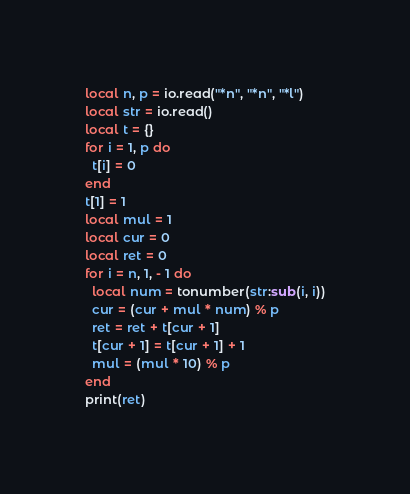<code> <loc_0><loc_0><loc_500><loc_500><_Lua_>local n, p = io.read("*n", "*n", "*l")
local str = io.read()
local t = {}
for i = 1, p do
  t[i] = 0
end
t[1] = 1
local mul = 1
local cur = 0
local ret = 0
for i = n, 1, - 1 do
  local num = tonumber(str:sub(i, i))
  cur = (cur + mul * num) % p
  ret = ret + t[cur + 1]
  t[cur + 1] = t[cur + 1] + 1
  mul = (mul * 10) % p
end
print(ret)
</code> 